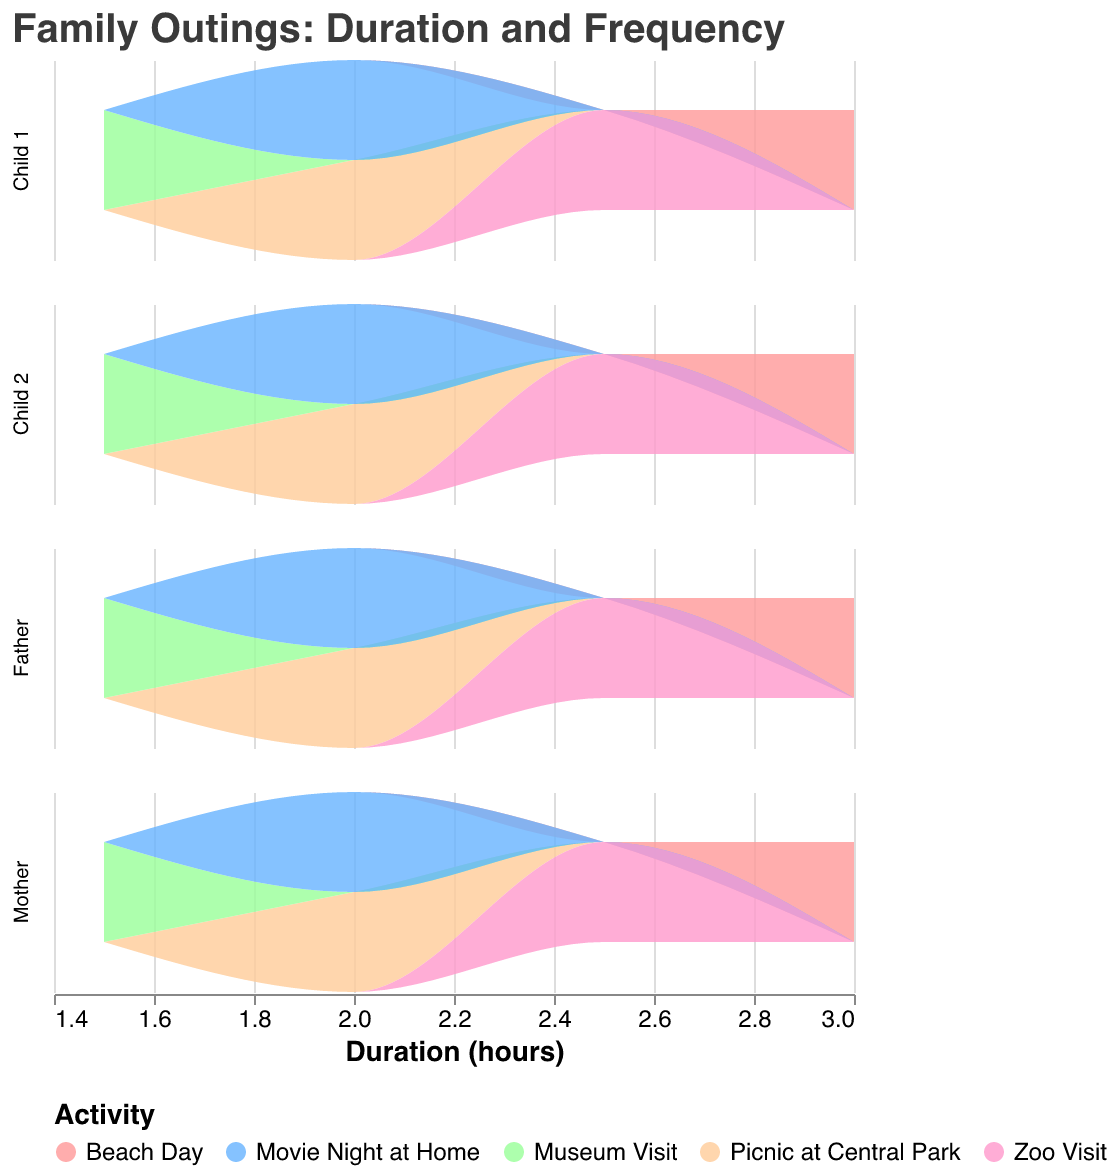What are the titles of the two axes? The x-axis is labeled "Duration (hours)" and there is no title for the y-axis in the individual subplots.
Answer: Duration (hours), None What is the total number of family outings during October? Count the number of data points in the figure, noting each outing involves four family members. There are five outings with four data points each, so the total number is 5 * 4 = 20.
Answer: 20 Which activity has the longest duration? The "Beach Day" activity shows the longest duration on the x-axis at 3 hours.
Answer: Beach Day Do most of the activities last for more than 2 hours? By observing the x-axis, we see "Picnic at Central Park," "Movie Night at Home," and "Zoo Visit" have durations of 2 or 2.5 hours respectively, while "Beach Day" surpasses the 2-hour mark. However, "Museum Visit" only lasts 1.5 hours, so not all activities last more than 2 hours.
Answer: No How many activities have a duration of exactly 2 hours? The "Picnic at Central Park" and "Movie Night at Home" activities both last exactly 2 hours.
Answer: 2 Which family member has the maximum number of outings? Since a subplot is created for each family member and all have identical plots, each family member participates in all outings.
Answer: All members have the same number of outings Do any of the activities repeat? By examining the legend and individual colors representing different activities, all activities appear unique without repeats during the month.
Answer: No Which activity has the highest frequency? Each activity column shows equal participation by all family members, with no activity outpacing the others in frequency. Therefore, all activities have the same frequency.
Answer: All activities have the same frequency 